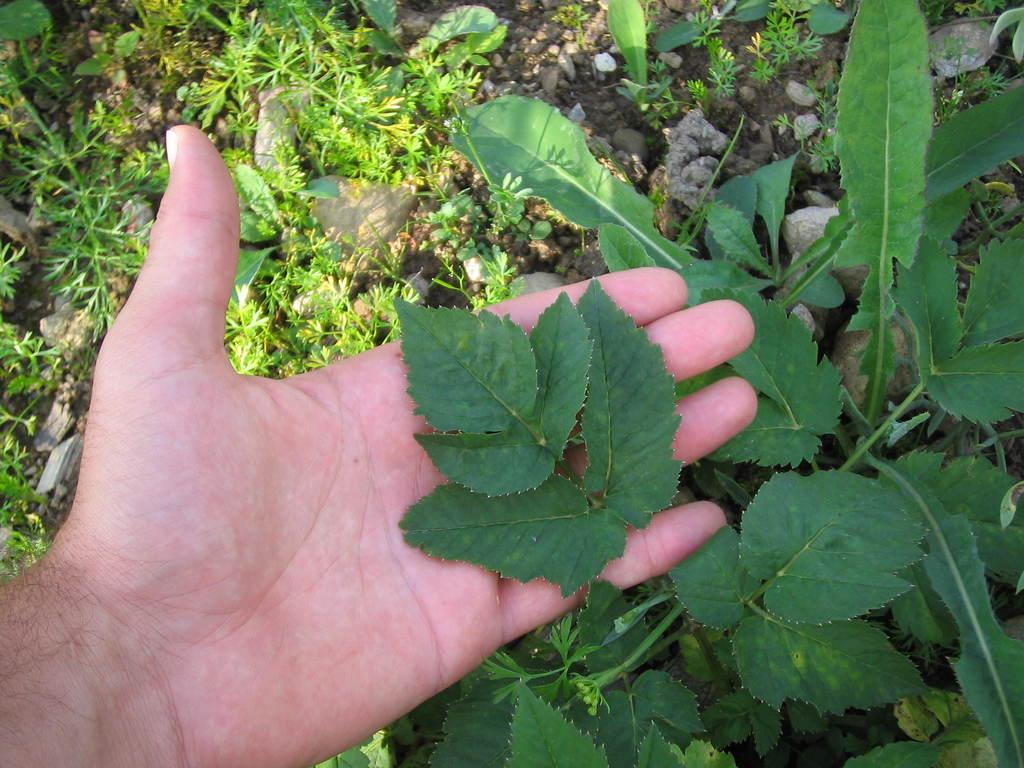What is on the person's hand in the image? There is a leaf on the person's hand in the image. What can be seen in the background of the image? There are stones and a plant visible in the background of the image. Can you tell me how many plates are on the person's hand in the image? There are no plates present on the person's hand in the image; only a leaf is visible. 